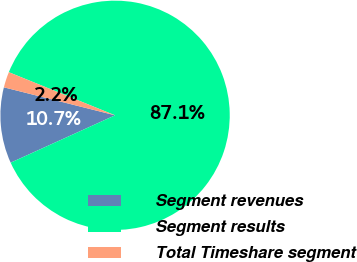Convert chart. <chart><loc_0><loc_0><loc_500><loc_500><pie_chart><fcel>Segment revenues<fcel>Segment results<fcel>Total Timeshare segment<nl><fcel>10.7%<fcel>87.08%<fcel>2.21%<nl></chart> 